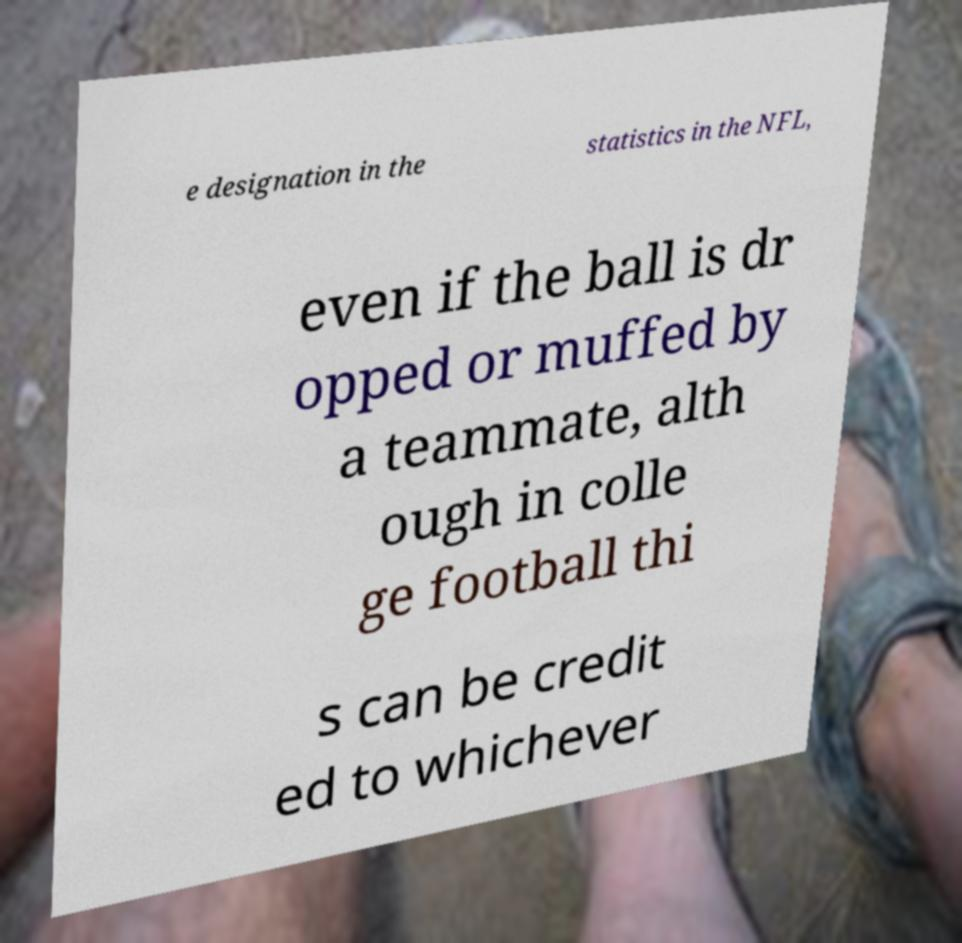Please identify and transcribe the text found in this image. e designation in the statistics in the NFL, even if the ball is dr opped or muffed by a teammate, alth ough in colle ge football thi s can be credit ed to whichever 